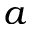Convert formula to latex. <formula><loc_0><loc_0><loc_500><loc_500>a</formula> 